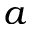Convert formula to latex. <formula><loc_0><loc_0><loc_500><loc_500>a</formula> 